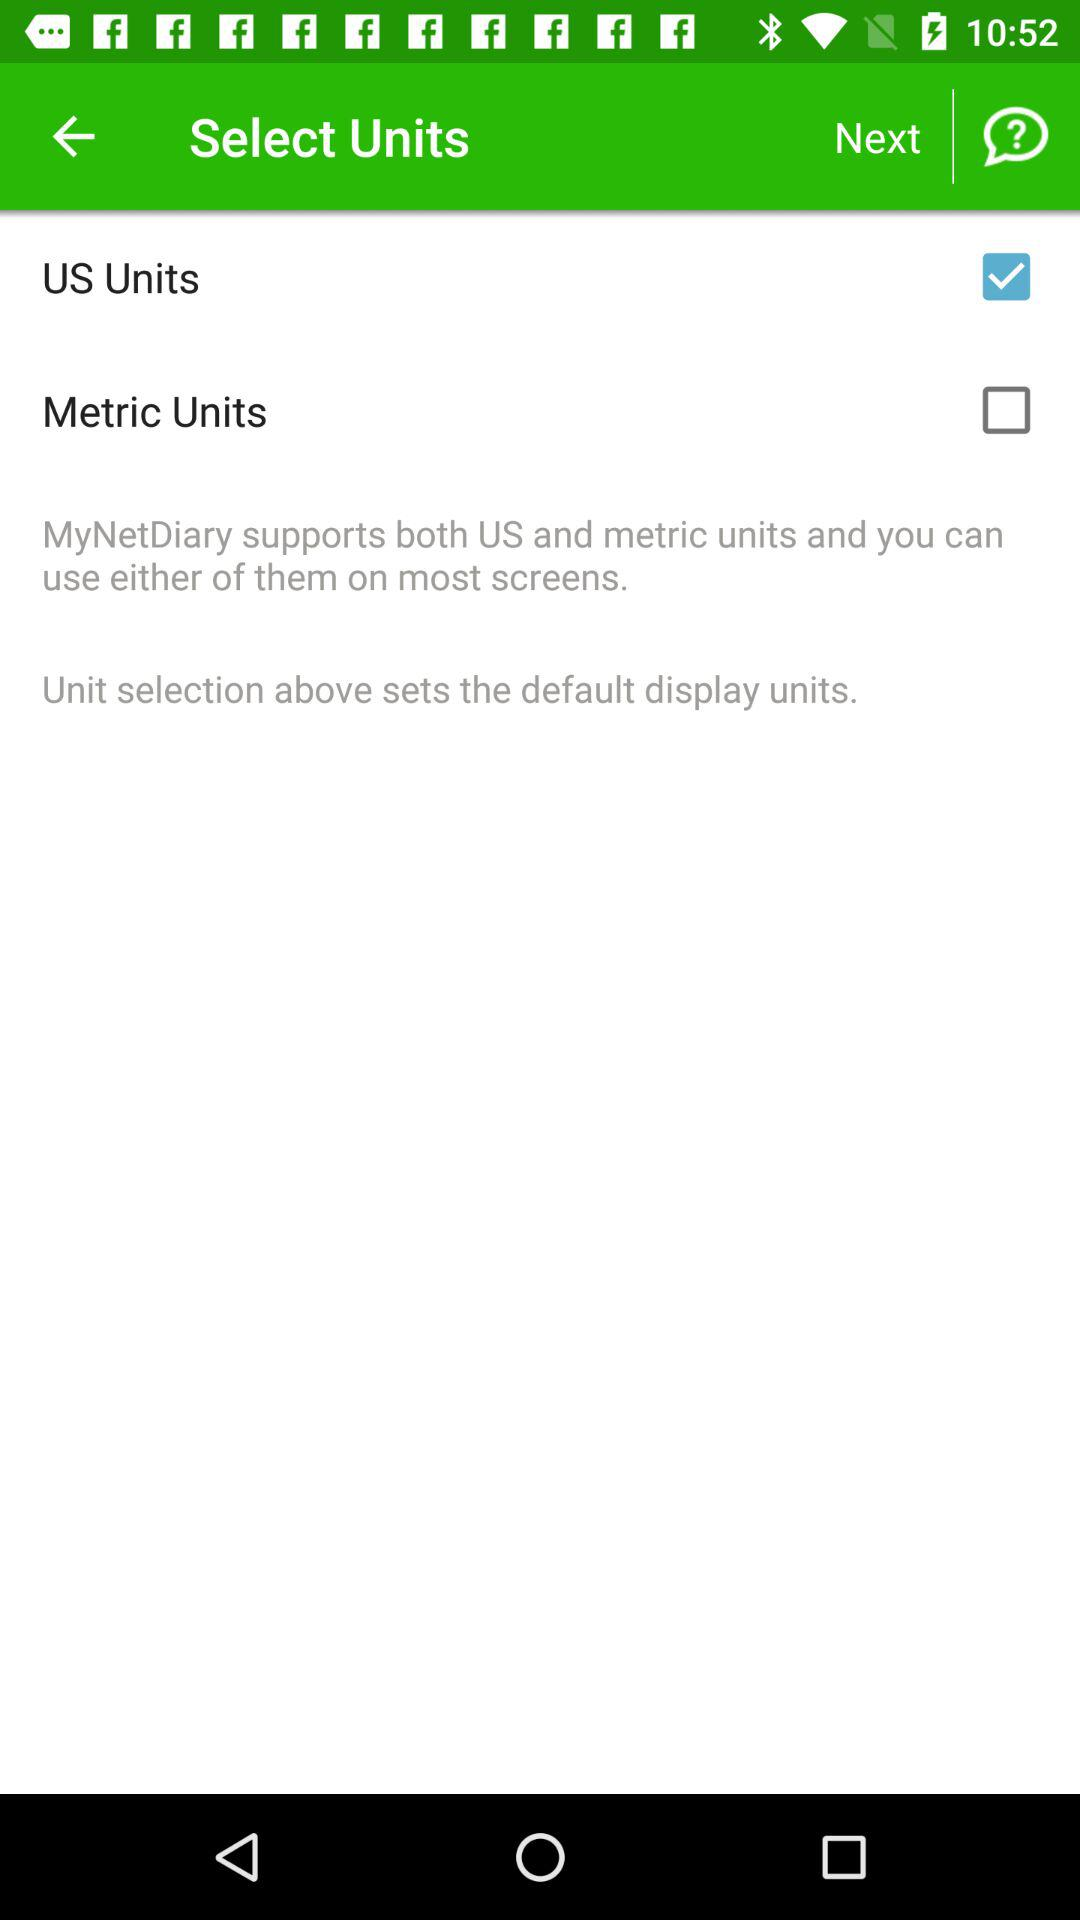How many checkbox are there on the screen?
Answer the question using a single word or phrase. 2 